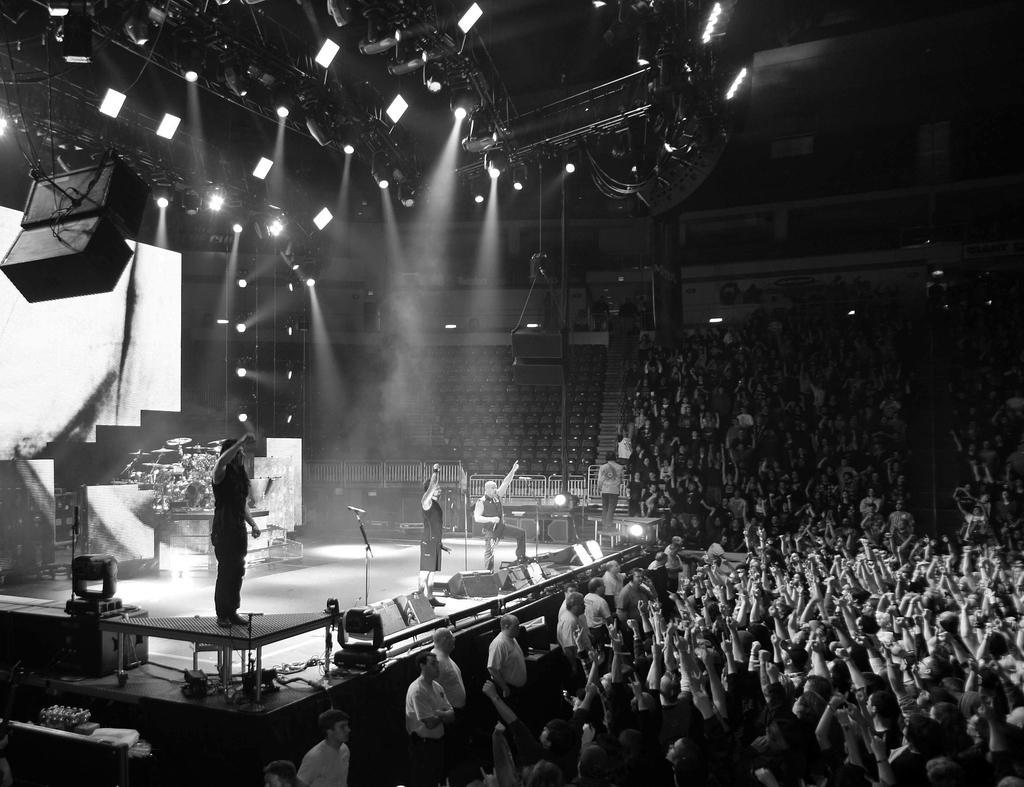Describe this image in one or two sentences. In this image we can see live show in a closed auditorium, at the right side of the image there are some spectators standing, at the left side of the image there are some persons standing on the stage playing musical instruments and singing at the top of the image there are some sound boxes, lights. 